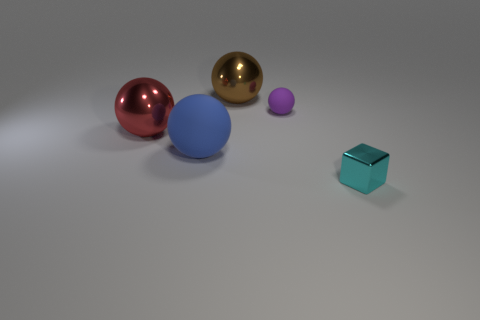There is a metal thing behind the red metal thing; how many things are to the left of it?
Keep it short and to the point. 2. There is a big brown metallic thing; what shape is it?
Ensure brevity in your answer.  Sphere. What shape is the big brown thing that is the same material as the tiny cyan cube?
Offer a terse response. Sphere. There is a large rubber thing in front of the tiny rubber ball; is its shape the same as the red thing?
Provide a short and direct response. Yes. What shape is the cyan thing right of the small sphere?
Your response must be concise. Cube. How many brown things are the same size as the cube?
Keep it short and to the point. 0. The tiny matte thing has what color?
Provide a succinct answer. Purple. The brown thing that is the same material as the block is what size?
Your answer should be very brief. Large. Is there a large cylinder of the same color as the small rubber ball?
Provide a short and direct response. No. What number of things are objects behind the small metallic block or big red metallic objects?
Keep it short and to the point. 4. 